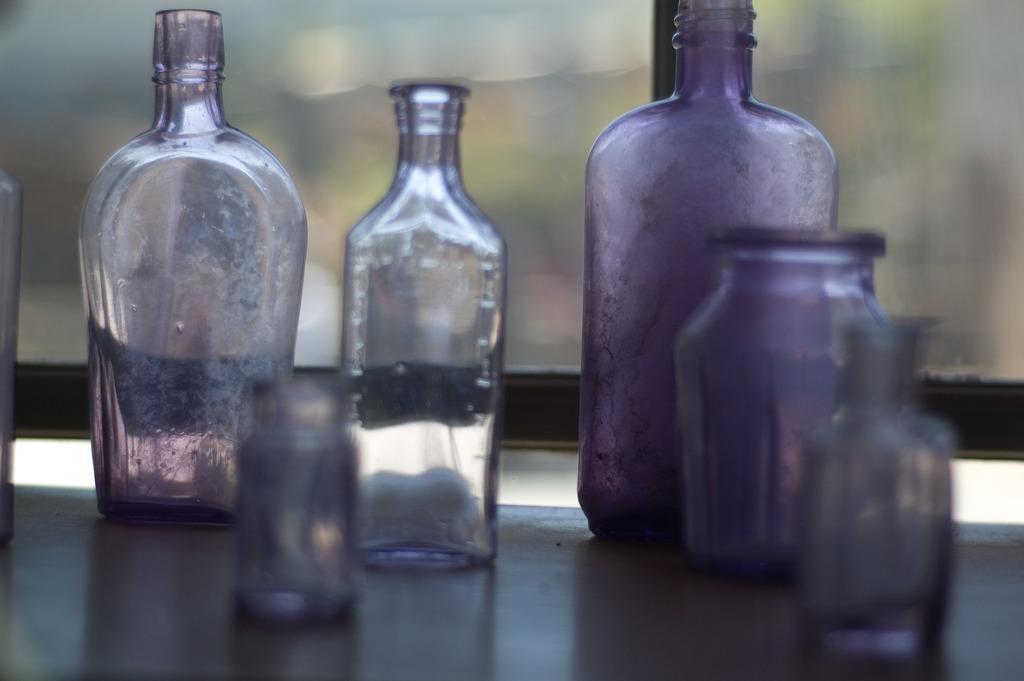In one or two sentences, can you explain what this image depicts? In this image I can see few glass bottles. 